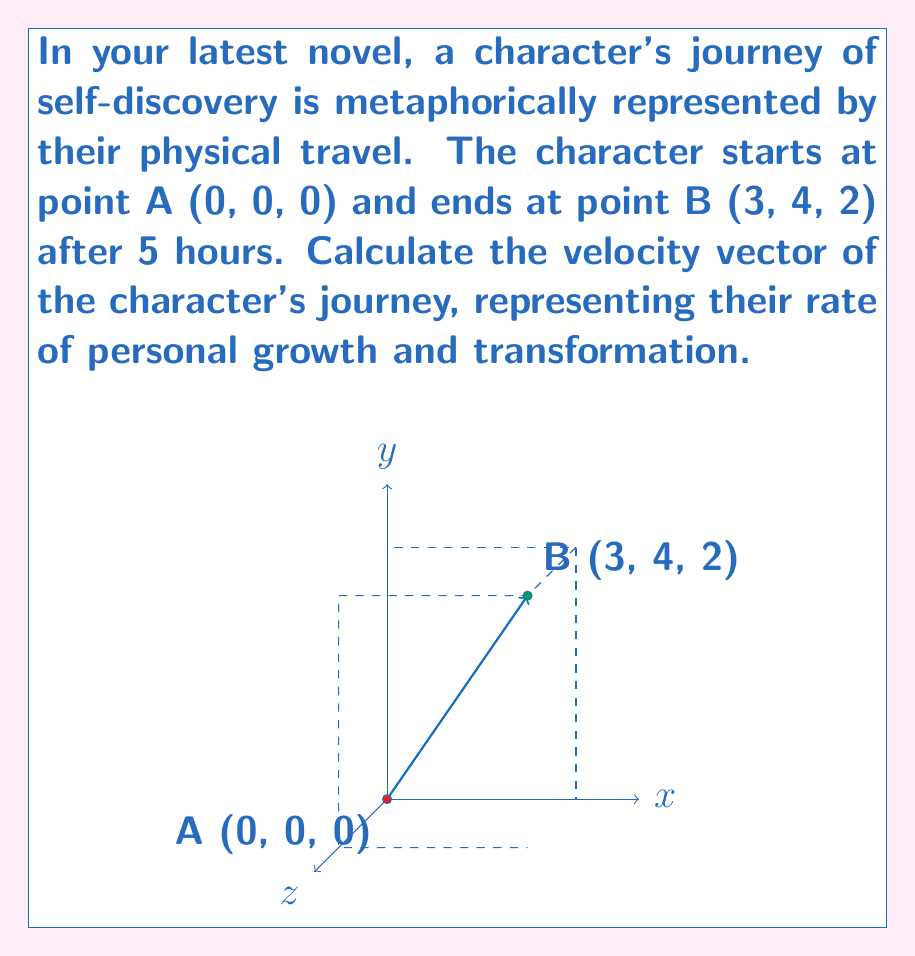Help me with this question. To calculate the velocity vector, we need to follow these steps:

1) First, let's determine the displacement vector $\vec{d}$:
   $$\vec{d} = \vec{B} - \vec{A} = (3-0, 4-0, 2-0) = (3, 4, 2)$$

2) The velocity vector $\vec{v}$ is defined as the displacement vector divided by the time taken:
   $$\vec{v} = \frac{\vec{d}}{t}$$

3) We know that the journey took 5 hours, so we can calculate the velocity vector:
   $$\vec{v} = \frac{(3, 4, 2)}{5} = (\frac{3}{5}, \frac{4}{5}, \frac{2}{5})$$

4) To interpret this metaphorically:
   - The x-component ($\frac{3}{5}$) could represent the rate of physical progress.
   - The y-component ($\frac{4}{5}$) could represent the rate of emotional growth.
   - The z-component ($\frac{2}{5}$) could represent the rate of spiritual development.

Thus, the velocity vector $(\frac{3}{5}, \frac{4}{5}, \frac{2}{5})$ represents the character's rate of transformation in these three aspects of their journey.
Answer: $\vec{v} = (\frac{3}{5}, \frac{4}{5}, \frac{2}{5})$ 